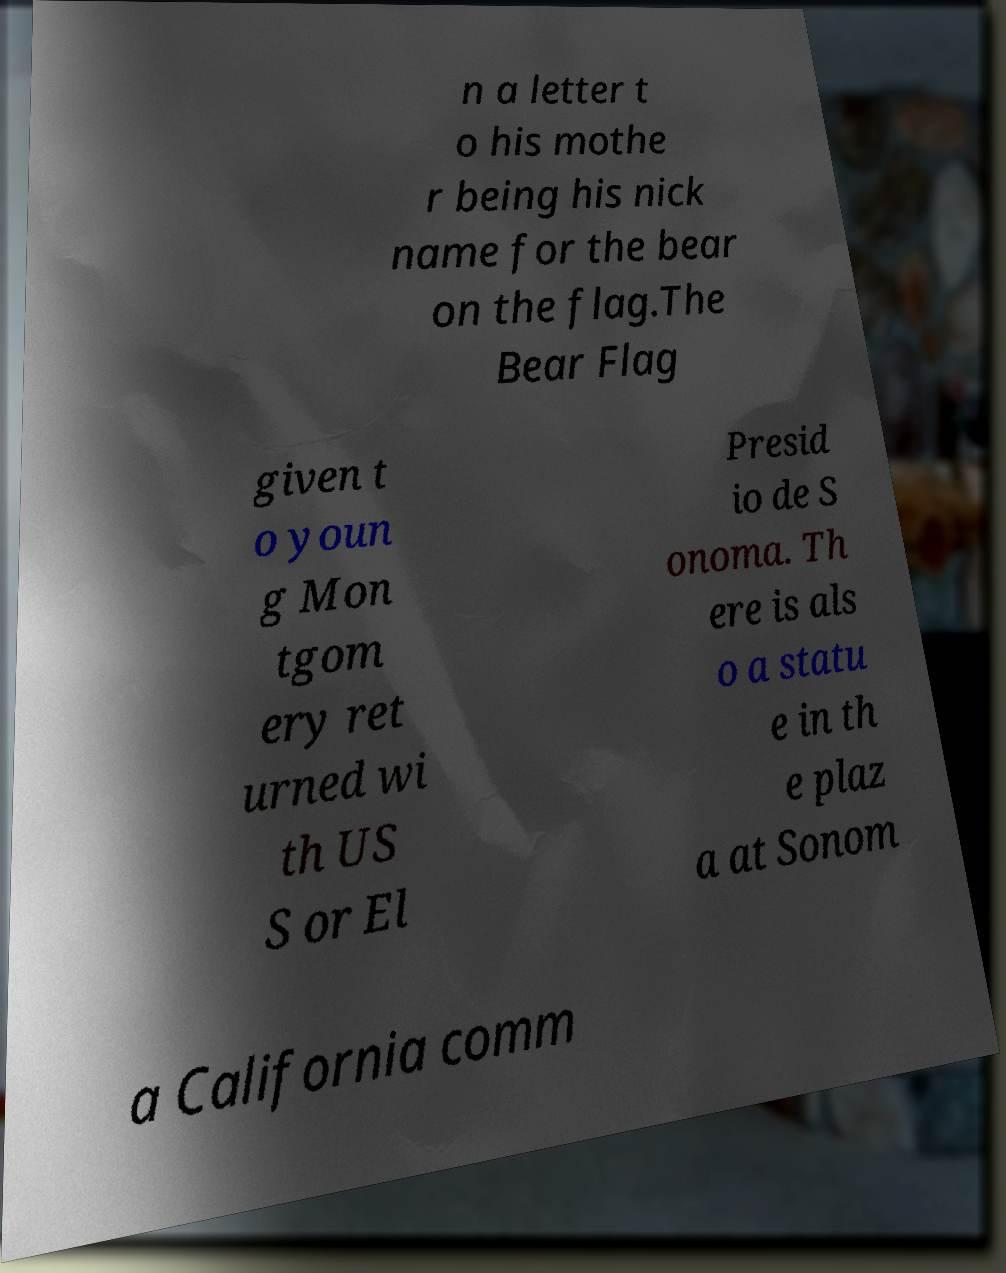Could you assist in decoding the text presented in this image and type it out clearly? n a letter t o his mothe r being his nick name for the bear on the flag.The Bear Flag given t o youn g Mon tgom ery ret urned wi th US S or El Presid io de S onoma. Th ere is als o a statu e in th e plaz a at Sonom a California comm 